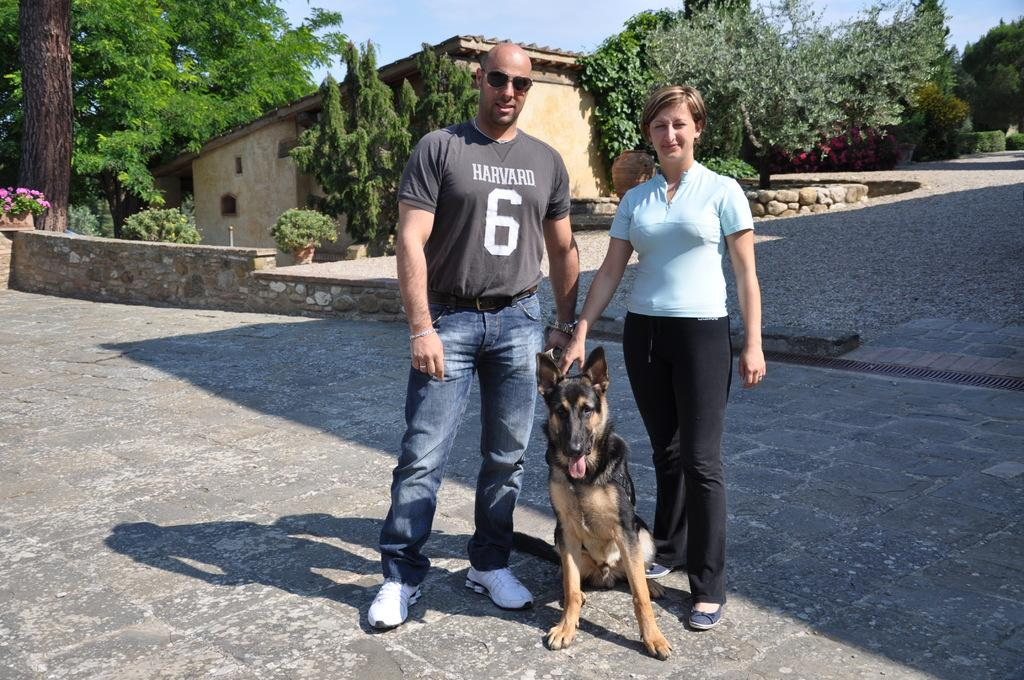Who is present in the image? There is a man and a woman in the image. What are the man and woman doing in the image? The man and woman are holding a dog in the image. What can be seen in the background of the image? There is a house and trees in the background of the image. What type of wax can be seen dripping from the goose in the image? There is no goose or wax present in the image. How many pigs are visible in the image? There are no pigs present in the image. 